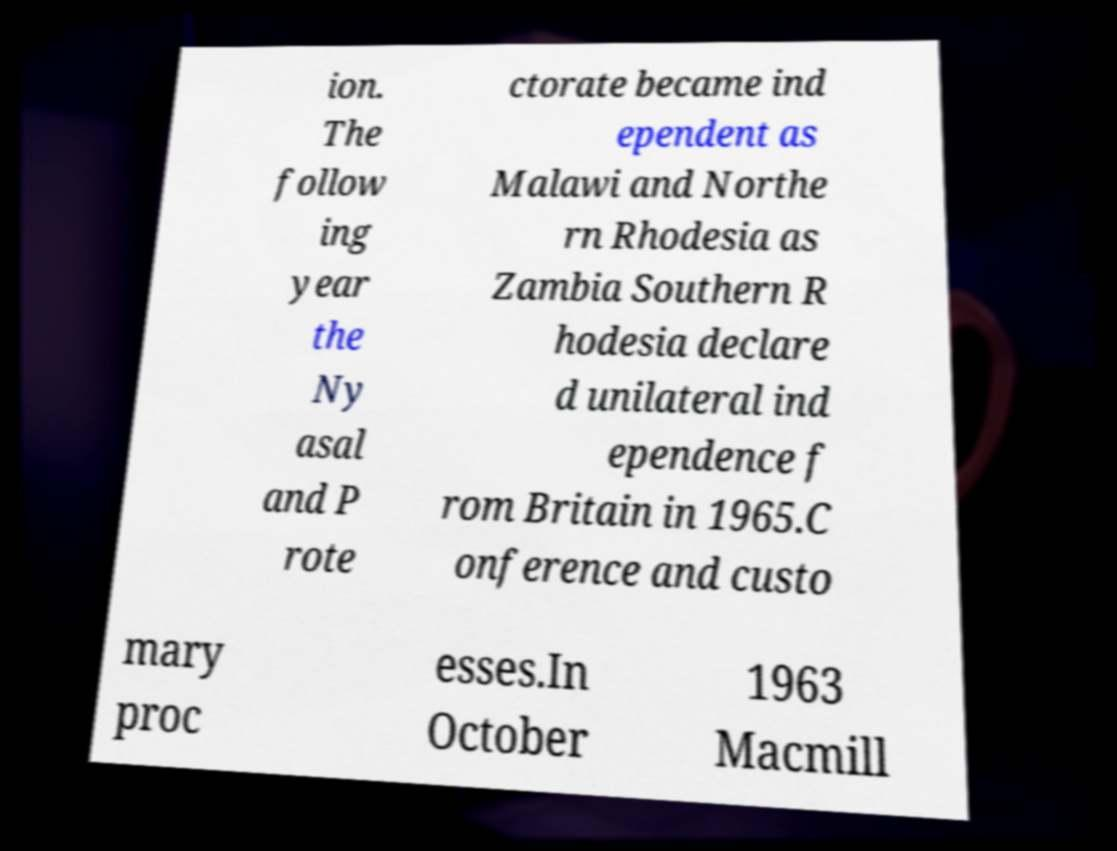For documentation purposes, I need the text within this image transcribed. Could you provide that? ion. The follow ing year the Ny asal and P rote ctorate became ind ependent as Malawi and Northe rn Rhodesia as Zambia Southern R hodesia declare d unilateral ind ependence f rom Britain in 1965.C onference and custo mary proc esses.In October 1963 Macmill 